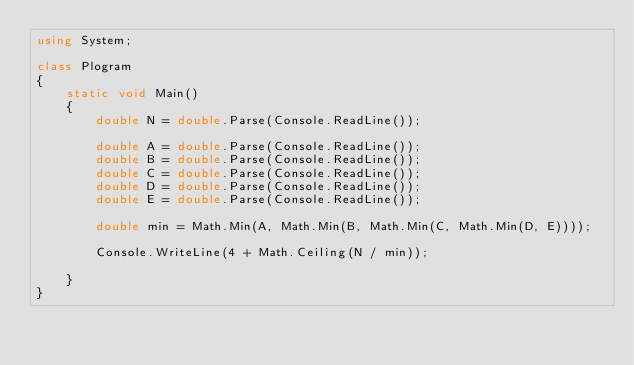<code> <loc_0><loc_0><loc_500><loc_500><_C#_>using System;

class Plogram
{
    static void Main()
    {
        double N = double.Parse(Console.ReadLine());

        double A = double.Parse(Console.ReadLine());
        double B = double.Parse(Console.ReadLine());
        double C = double.Parse(Console.ReadLine());
        double D = double.Parse(Console.ReadLine());
        double E = double.Parse(Console.ReadLine());

        double min = Math.Min(A, Math.Min(B, Math.Min(C, Math.Min(D, E))));

        Console.WriteLine(4 + Math.Ceiling(N / min));

    }
}</code> 